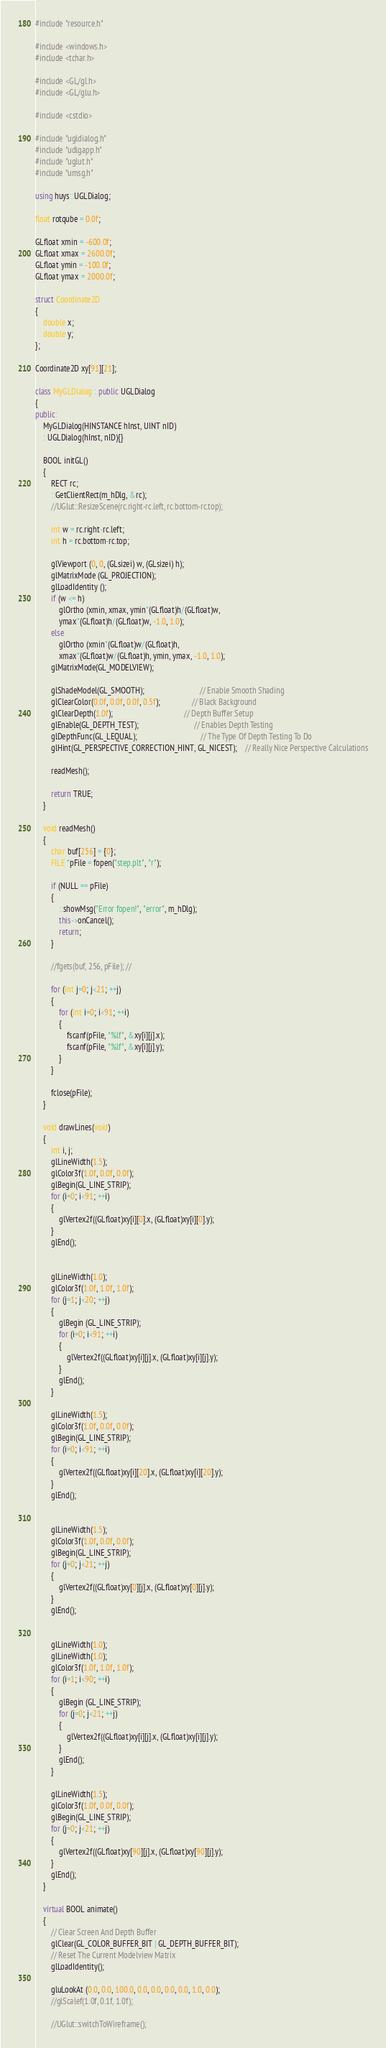<code> <loc_0><loc_0><loc_500><loc_500><_C++_>#include "resource.h"

#include <windows.h>
#include <tchar.h>

#include <GL/gl.h>
#include <GL/glu.h>

#include <cstdio>

#include "ugldialog.h"
#include "udlgapp.h"
#include "uglut.h"
#include "umsg.h"

using huys::UGLDialog;

float rotqube = 0.0f;

GLfloat xmin = -600.0f;
GLfloat xmax = 2600.0f;
GLfloat ymin = -100.0f;
GLfloat ymax = 2000.0f;

struct Coordinate2D
{
    double x;
    double y;
};

Coordinate2D xy[91][21];

class MyGLDialog : public UGLDialog
{
public:
    MyGLDialog(HINSTANCE hInst, UINT nID)
    : UGLDialog(hInst, nID){}

    BOOL initGL()
    {
        RECT rc;
        ::GetClientRect(m_hDlg, &rc);
        //UGlut::ResizeScene(rc.right-rc.left, rc.bottom-rc.top);

        int w = rc.right-rc.left;
        int h = rc.bottom-rc.top;

        glViewport (0, 0, (GLsizei) w, (GLsizei) h);
        glMatrixMode (GL_PROJECTION);
        glLoadIdentity ();
        if (w <= h)
            glOrtho (xmin, xmax, ymin*(GLfloat)h/(GLfloat)w,
            ymax*(GLfloat)h/(GLfloat)w, -1.0, 1.0);
        else
            glOrtho (xmin*(GLfloat)w/(GLfloat)h,
            xmax*(GLfloat)w/(GLfloat)h, ymin, ymax, -1.0, 1.0);
        glMatrixMode(GL_MODELVIEW);

        glShadeModel(GL_SMOOTH);                            // Enable Smooth Shading
        glClearColor(0.0f, 0.0f, 0.0f, 0.5f);                // Black Background
        glClearDepth(1.0f);                                    // Depth Buffer Setup
        glEnable(GL_DEPTH_TEST);                            // Enables Depth Testing
        glDepthFunc(GL_LEQUAL);                                // The Type Of Depth Testing To Do
        glHint(GL_PERSPECTIVE_CORRECTION_HINT, GL_NICEST);    // Really Nice Perspective Calculations

        readMesh();

        return TRUE;
    }

    void readMesh()
    {
        char buf[256] = {0};
        FILE *pFile = fopen("step.plt", "r");

        if (NULL == pFile)
        {
            ::showMsg("Error fopen!", "error", m_hDlg);
            this->onCancel();
            return;
        }

        //fgets(buf, 256, pFile); //

        for (int j=0; j<21; ++j)
        {
            for (int i=0; i<91; ++i)
            {
                fscanf(pFile, "%lf", &xy[i][j].x);
                fscanf(pFile, "%lf", &xy[i][j].y);
            }
        }

        fclose(pFile);
    }

    void drawLines(void)
    {
        int i, j;
        glLineWidth(1.5);
        glColor3f(1.0f, 0.0f, 0.0f);
        glBegin(GL_LINE_STRIP);
        for (i=0; i<91; ++i)
        {
            glVertex2f((GLfloat)xy[i][0].x, (GLfloat)xy[i][0].y);
        }
        glEnd();


        glLineWidth(1.0);
        glColor3f(1.0f, 1.0f, 1.0f);
        for (j=1; j<20; ++j)
        {
            glBegin (GL_LINE_STRIP);
            for (i=0; i<91; ++i)
            {
                glVertex2f((GLfloat)xy[i][j].x, (GLfloat)xy[i][j].y);
            }
            glEnd();
        }

        glLineWidth(1.5);
        glColor3f(1.0f, 0.0f, 0.0f);
        glBegin(GL_LINE_STRIP);
        for (i=0; i<91; ++i)
        {
            glVertex2f((GLfloat)xy[i][20].x, (GLfloat)xy[i][20].y);
        }
        glEnd();


        glLineWidth(1.5);
        glColor3f(1.0f, 0.0f, 0.0f);
        glBegin(GL_LINE_STRIP);
        for (j=0; j<21; ++j)
        {
            glVertex2f((GLfloat)xy[0][j].x, (GLfloat)xy[0][j].y);
        }
        glEnd();


        glLineWidth(1.0);
        glLineWidth(1.0);
        glColor3f(1.0f, 1.0f, 1.0f);
        for (i=1; i<90; ++i)
        {
            glBegin (GL_LINE_STRIP);
            for (j=0; j<21; ++j)
            {
                glVertex2f((GLfloat)xy[i][j].x, (GLfloat)xy[i][j].y);
            }
            glEnd();
        }

        glLineWidth(1.5);
        glColor3f(1.0f, 0.0f, 0.0f);
        glBegin(GL_LINE_STRIP);
        for (j=0; j<21; ++j)
        {
            glVertex2f((GLfloat)xy[90][j].x, (GLfloat)xy[90][j].y);
        }
        glEnd();
    }

    virtual BOOL animate()
    {
        // Clear Screen And Depth Buffer
        glClear(GL_COLOR_BUFFER_BIT | GL_DEPTH_BUFFER_BIT);
        // Reset The Current Modelview Matrix
        glLoadIdentity();

        gluLookAt (0.0, 0.0, 100.0, 0.0, 0.0, 0.0, 0.0, 1.0, 0.0);
        //glScalef(1.0f, 0.1f, 1.0f);

        //UGlut::switchToWireframe();

</code> 